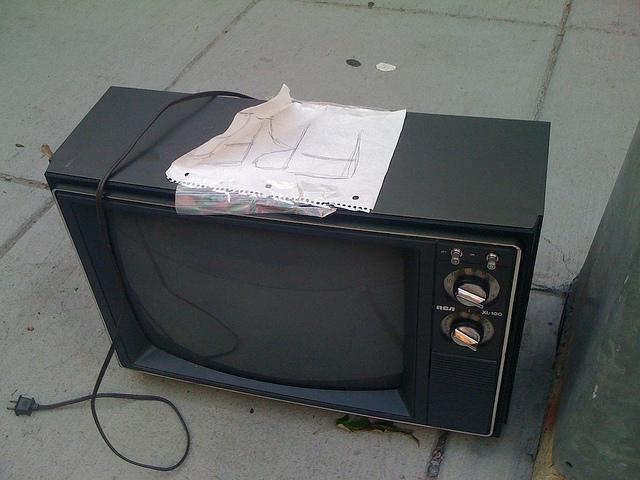What does the sign say?
Give a very brief answer. Free. What is this device?
Answer briefly. Tv. How many knobs are there?
Quick response, please. 4. Where is the television?
Give a very brief answer. Sidewalk. What is written on the sticky note of the TV?
Give a very brief answer. Free. 